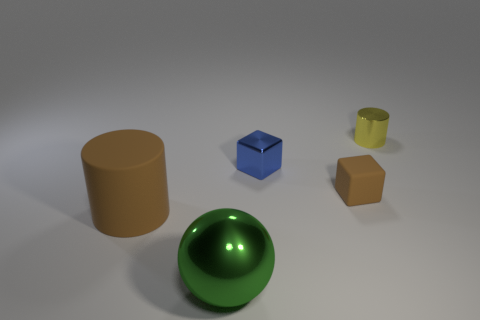How many green things are matte things or shiny spheres?
Make the answer very short. 1. What color is the big object that is the same material as the small brown block?
Provide a succinct answer. Brown. How many small objects are either blue metal objects or brown matte objects?
Make the answer very short. 2. Is the number of brown cubes less than the number of matte balls?
Give a very brief answer. No. There is a big rubber thing that is the same shape as the small yellow shiny thing; what color is it?
Offer a terse response. Brown. Are there any other things that have the same shape as the large green object?
Give a very brief answer. No. Is the number of tiny cylinders greater than the number of blue balls?
Provide a short and direct response. Yes. What number of other things are made of the same material as the small brown thing?
Provide a short and direct response. 1. What is the shape of the thing in front of the brown rubber thing that is left of the tiny metal object in front of the small metal cylinder?
Your answer should be compact. Sphere. Are there fewer blue objects behind the small blue metallic block than brown cylinders to the left of the rubber cube?
Make the answer very short. Yes. 